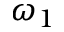<formula> <loc_0><loc_0><loc_500><loc_500>\omega _ { 1 }</formula> 